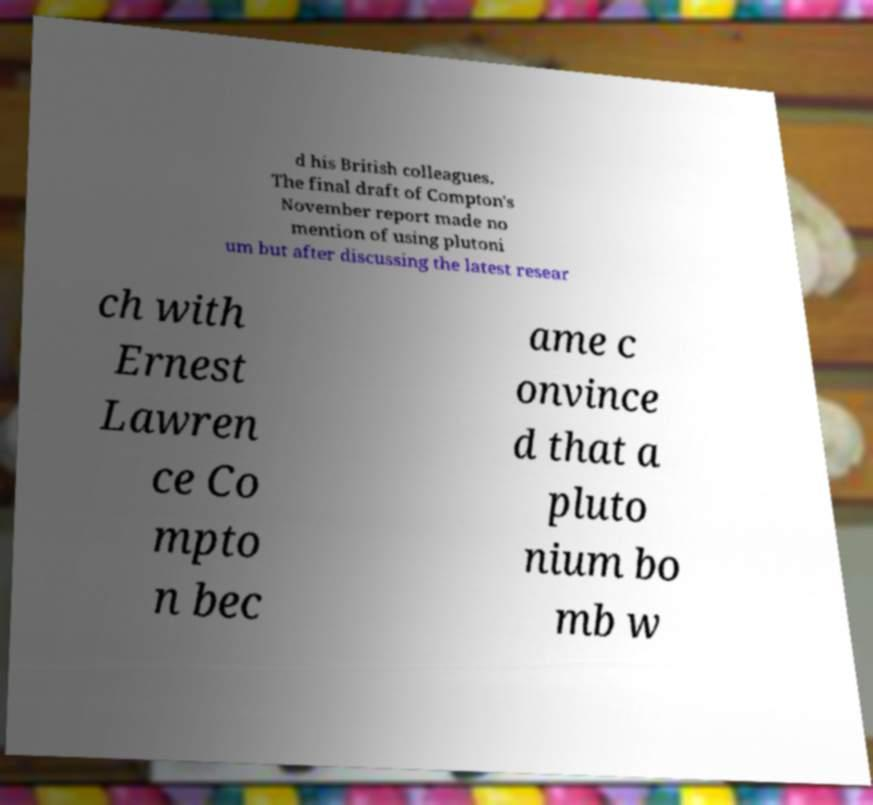Please read and relay the text visible in this image. What does it say? d his British colleagues. The final draft of Compton's November report made no mention of using plutoni um but after discussing the latest resear ch with Ernest Lawren ce Co mpto n bec ame c onvince d that a pluto nium bo mb w 